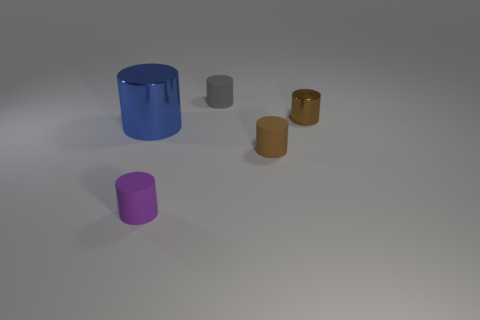Subtract all large metallic cylinders. How many cylinders are left? 4 Subtract all gray cylinders. How many cylinders are left? 4 Add 4 small gray cylinders. How many objects exist? 9 Subtract all blue cubes. How many brown cylinders are left? 2 Subtract 2 cylinders. How many cylinders are left? 3 Subtract 0 yellow cylinders. How many objects are left? 5 Subtract all red cylinders. Subtract all red balls. How many cylinders are left? 5 Subtract all big yellow rubber spheres. Subtract all brown shiny cylinders. How many objects are left? 4 Add 3 brown matte cylinders. How many brown matte cylinders are left? 4 Add 5 small brown things. How many small brown things exist? 7 